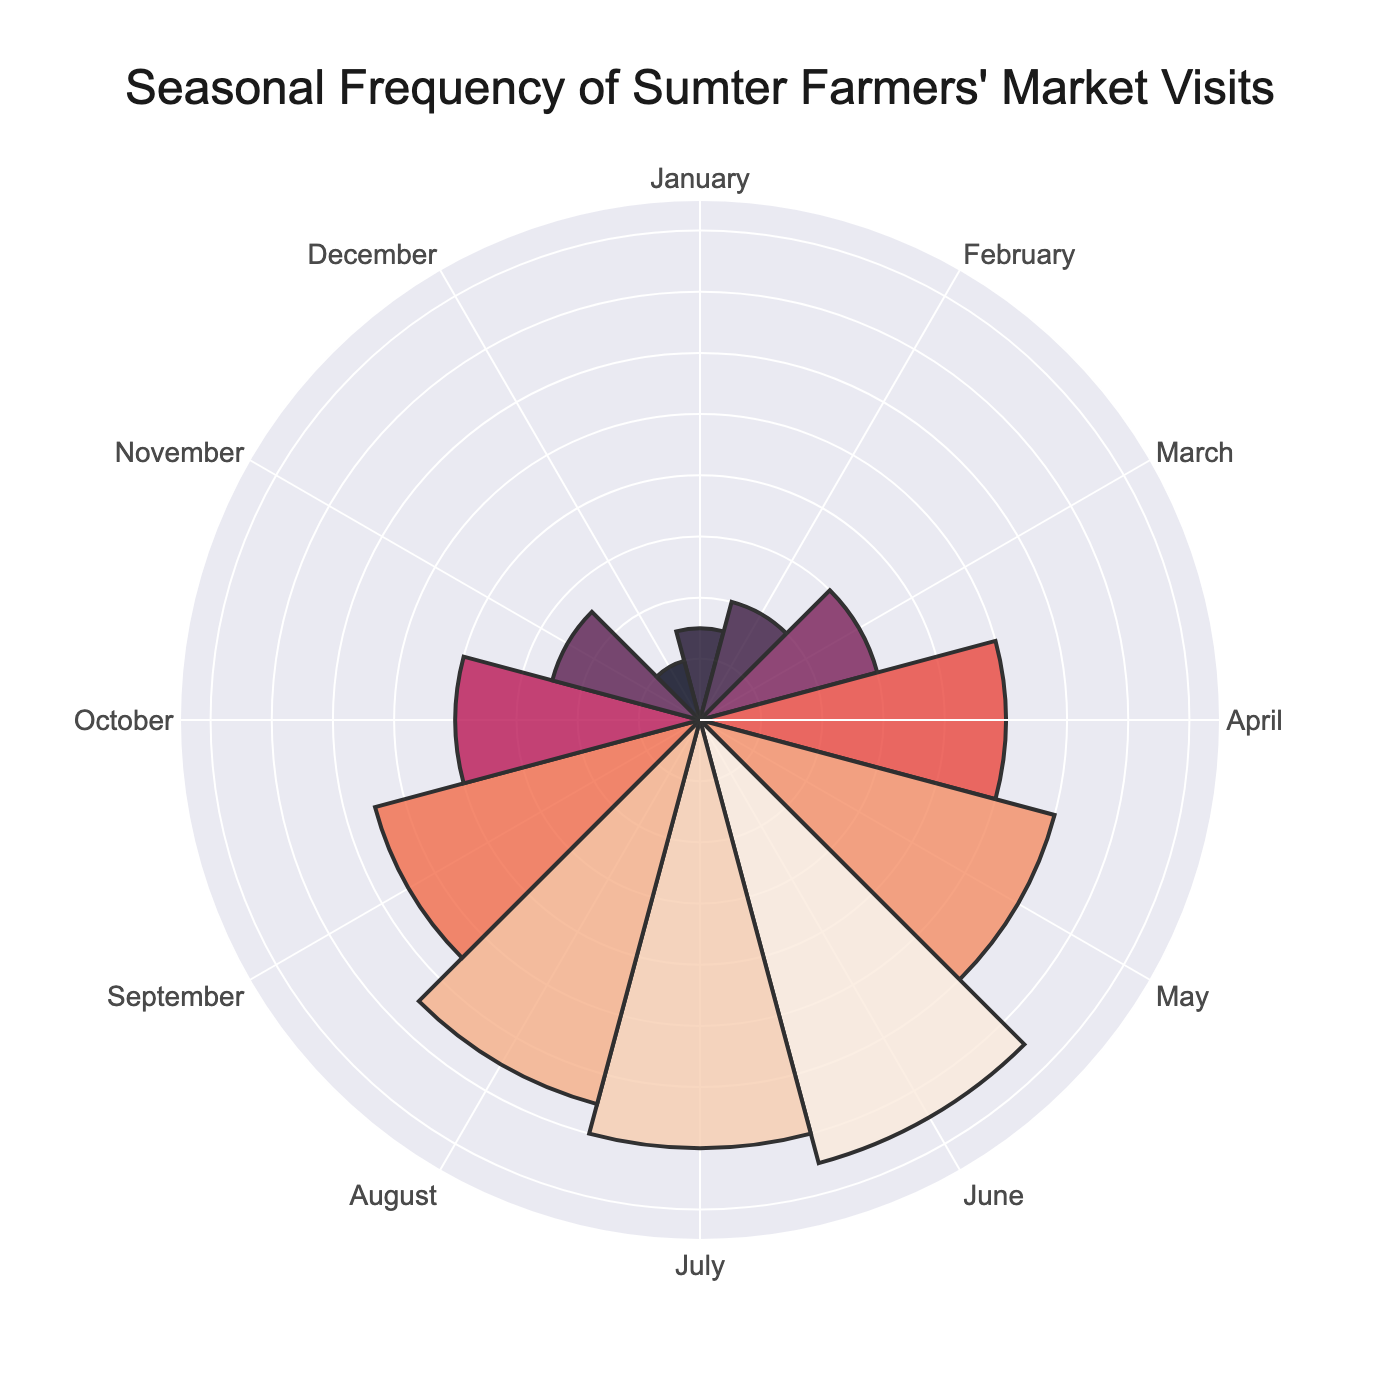What is the title of the chart? The title is usually placed at the top of the chart and summarises what the chart represents.
Answer: Seasonal Frequency of Sumter Farmers' Market Visits Which month had the highest number of visits to the Sumter Farmers Market? To identify the month with the highest number of visits, look at the radial bars and identify the bar with the greatest length.
Answer: June How many visits were recorded for the Sumter Farmers Market in December? To find the number of visits in December, locate the corresponding bar and read its magnitude.
Answer: 2 What is the average number of visits per month? Sum all the monthly visits and divide by the number of months (12). Total visits = 3+4+6+10+12+15+14+13+11+8+5+2 = 103. So, the average is 103/12.
Answer: 8.58 How much higher were the visits in April compared to January? Subtract the number of visits in January from the visits in April: 10 (April) - 3 (January).
Answer: 7 Which two months had the least visits, and what were the total visits for those months? Identify the two months with the smallest radial bars and sum their visits. The two months are December (2) and January (3), so their total is 2 + 3.
Answer: December and January, 5 Is the number of visits in July greater than or equal to the visits in March? Compare the radial lengths for March (6) and July (14). July's length is greater than March's.
Answer: Yes Which season (Winter, Spring, Summer, Autumn) had the highest total visits, and what is the sum for that season? Sum the visits for each season:
- Winter: December, January, February -> 2+3+4 = 9
- Spring: March, April, May -> 6+10+12 = 28
- Summer: June, July, August -> 15+14+13 = 42
- Autumn: September, October, November -> 11+8+5 = 24. Summer has the highest total.
Answer: Summer, 42 By what percentage did the visits in November decrease compared to October? First, calculate the difference: October (8) - November (5) = 3. Then, use the formula (decrease/original value) * 100 = (3/8) * 100.
Answer: 37.5% In which month did the Sumter Farmers Market see a sharp decline in visits compared to the prior month and how many visits were lost? Look for the steepest drop in the radial bar lengths from one month to the next. The largest drop occurs from August (13) to September (11), resulting in a decline of 2 visits.
Answer: August to September, 2 visits 